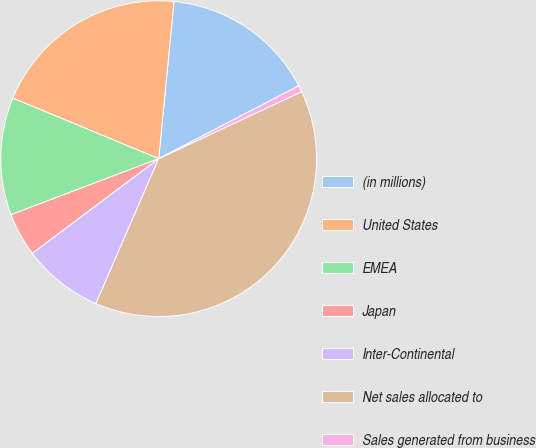Convert chart. <chart><loc_0><loc_0><loc_500><loc_500><pie_chart><fcel>(in millions)<fcel>United States<fcel>EMEA<fcel>Japan<fcel>Inter-Continental<fcel>Net sales allocated to<fcel>Sales generated from business<nl><fcel>15.82%<fcel>20.29%<fcel>12.03%<fcel>4.47%<fcel>8.25%<fcel>38.49%<fcel>0.66%<nl></chart> 